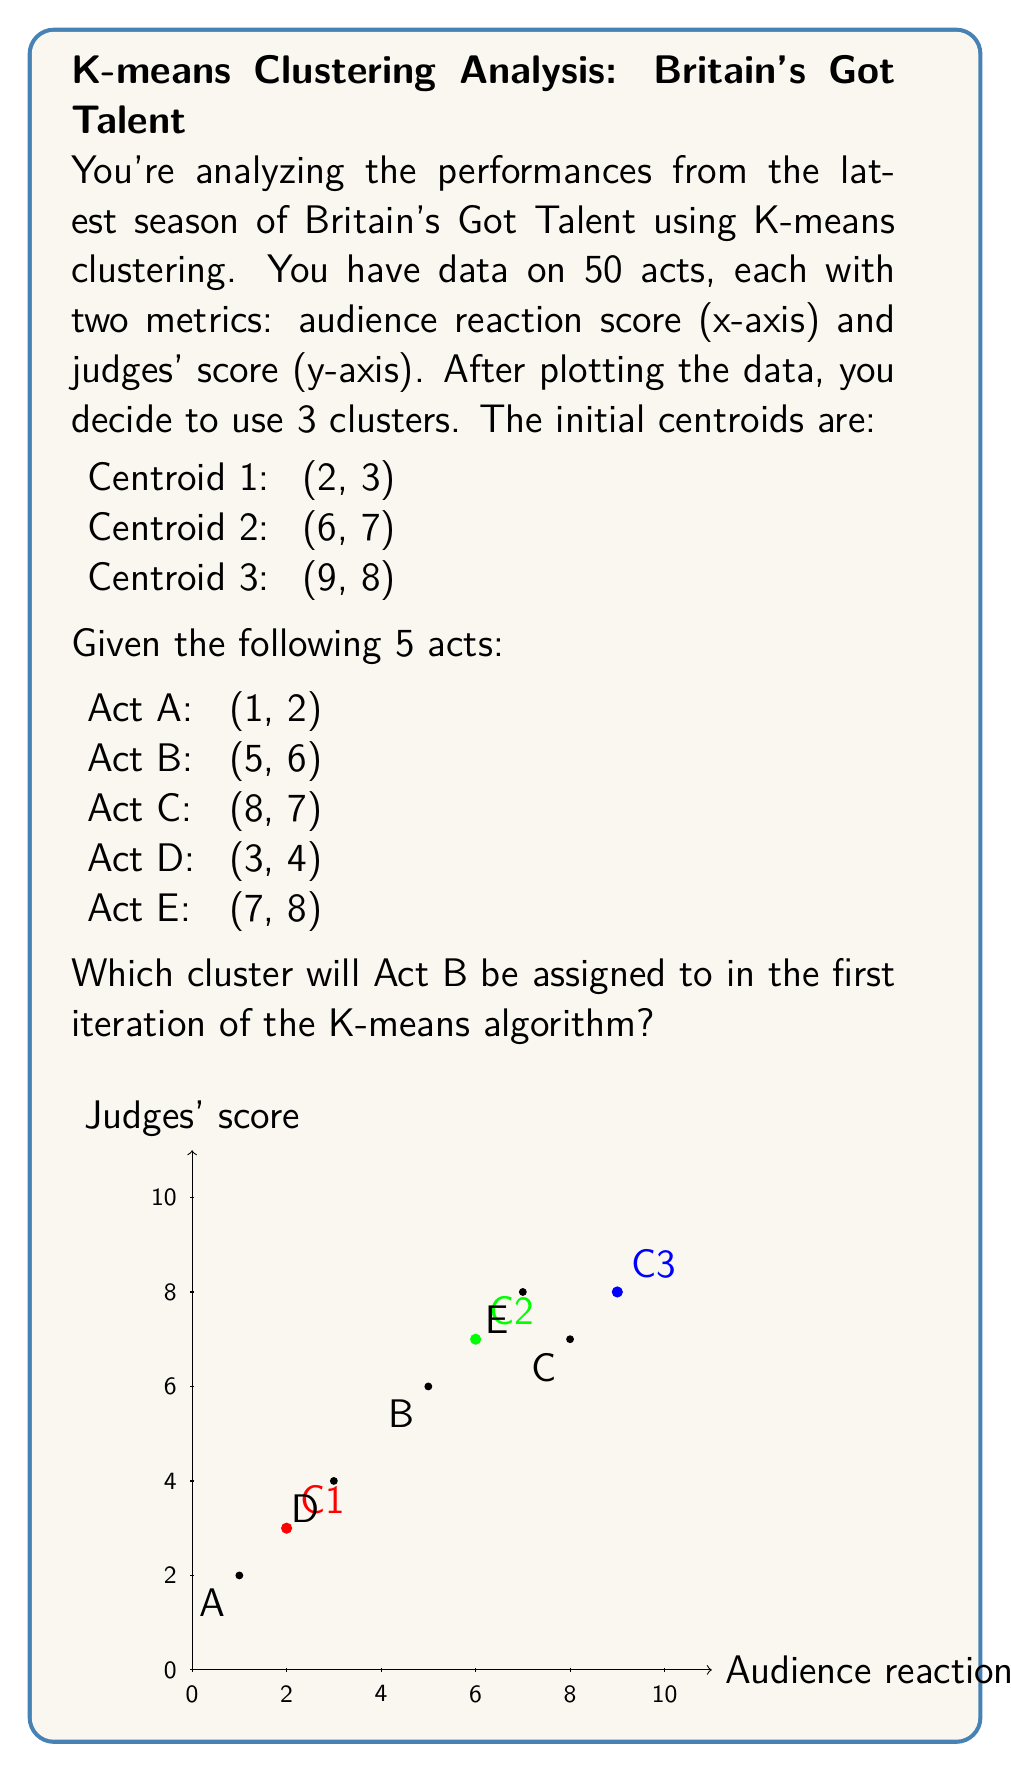Teach me how to tackle this problem. To solve this problem, we need to follow these steps:

1) In K-means clustering, each point is assigned to the cluster with the nearest centroid. We determine this by calculating the Euclidean distance between the point and each centroid.

2) The Euclidean distance in 2D space is given by the formula:

   $$d = \sqrt{(x_2 - x_1)^2 + (y_2 - y_1)^2}$$

3) Let's calculate the distance between Act B (5, 6) and each centroid:

   For Centroid 1 (2, 3):
   $$d_1 = \sqrt{(5 - 2)^2 + (6 - 3)^2} = \sqrt{3^2 + 3^2} = \sqrt{18} \approx 4.24$$

   For Centroid 2 (6, 7):
   $$d_2 = \sqrt{(5 - 6)^2 + (6 - 7)^2} = \sqrt{(-1)^2 + (-1)^2} = \sqrt{2} \approx 1.41$$

   For Centroid 3 (9, 8):
   $$d_3 = \sqrt{(5 - 9)^2 + (6 - 8)^2} = \sqrt{(-4)^2 + (-2)^2} = \sqrt{20} \approx 4.47$$

4) The smallest distance is to Centroid 2, with a distance of approximately 1.41.

Therefore, in the first iteration of the K-means algorithm, Act B will be assigned to the cluster represented by Centroid 2.
Answer: Cluster 2 